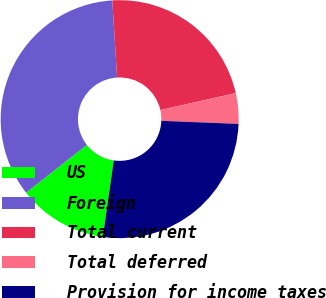Convert chart to OTSL. <chart><loc_0><loc_0><loc_500><loc_500><pie_chart><fcel>US<fcel>Foreign<fcel>Total current<fcel>Total deferred<fcel>Provision for income taxes<nl><fcel>12.14%<fcel>34.61%<fcel>22.47%<fcel>4.15%<fcel>26.62%<nl></chart> 